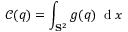<formula> <loc_0><loc_0><loc_500><loc_500>\mathcal { C } ( q ) = \int _ { S ^ { 2 } } g ( q ) \, d x</formula> 